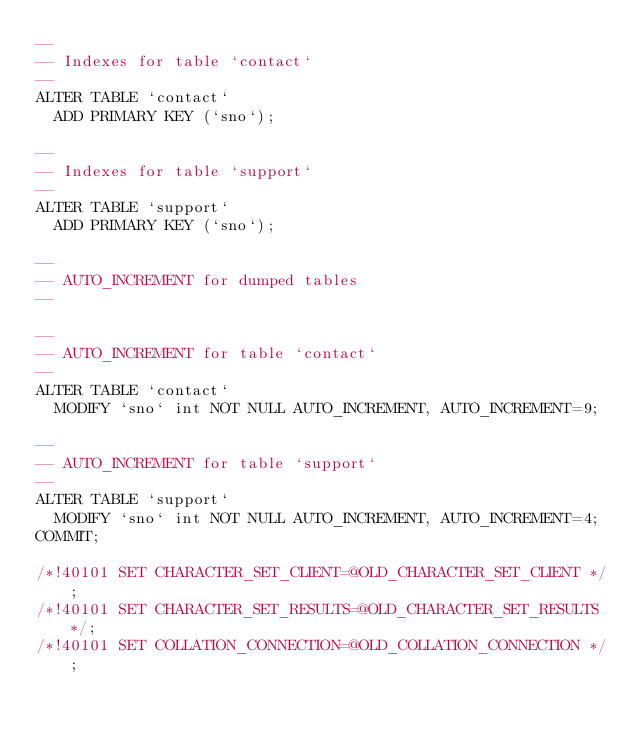Convert code to text. <code><loc_0><loc_0><loc_500><loc_500><_SQL_>--
-- Indexes for table `contact`
--
ALTER TABLE `contact`
  ADD PRIMARY KEY (`sno`);

--
-- Indexes for table `support`
--
ALTER TABLE `support`
  ADD PRIMARY KEY (`sno`);

--
-- AUTO_INCREMENT for dumped tables
--

--
-- AUTO_INCREMENT for table `contact`
--
ALTER TABLE `contact`
  MODIFY `sno` int NOT NULL AUTO_INCREMENT, AUTO_INCREMENT=9;

--
-- AUTO_INCREMENT for table `support`
--
ALTER TABLE `support`
  MODIFY `sno` int NOT NULL AUTO_INCREMENT, AUTO_INCREMENT=4;
COMMIT;

/*!40101 SET CHARACTER_SET_CLIENT=@OLD_CHARACTER_SET_CLIENT */;
/*!40101 SET CHARACTER_SET_RESULTS=@OLD_CHARACTER_SET_RESULTS */;
/*!40101 SET COLLATION_CONNECTION=@OLD_COLLATION_CONNECTION */;
</code> 